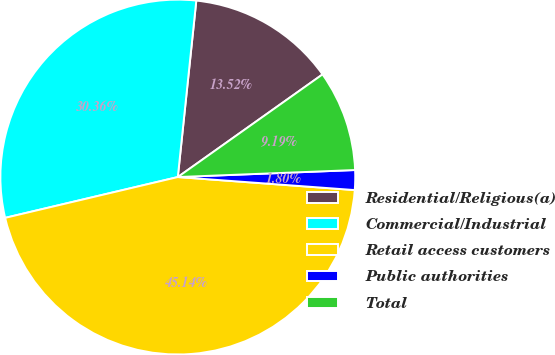<chart> <loc_0><loc_0><loc_500><loc_500><pie_chart><fcel>Residential/Religious(a)<fcel>Commercial/Industrial<fcel>Retail access customers<fcel>Public authorities<fcel>Total<nl><fcel>13.52%<fcel>30.36%<fcel>45.14%<fcel>1.8%<fcel>9.19%<nl></chart> 